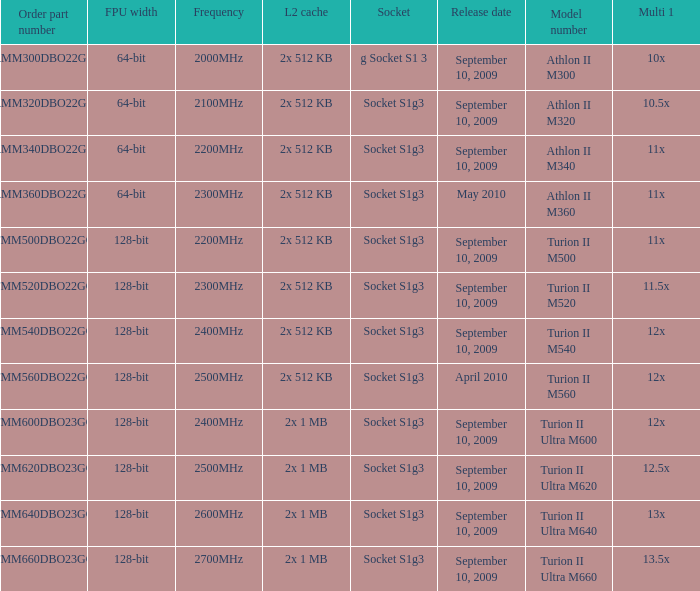What is the L2 cache with a 13.5x multi 1? 2x 1 MB. 